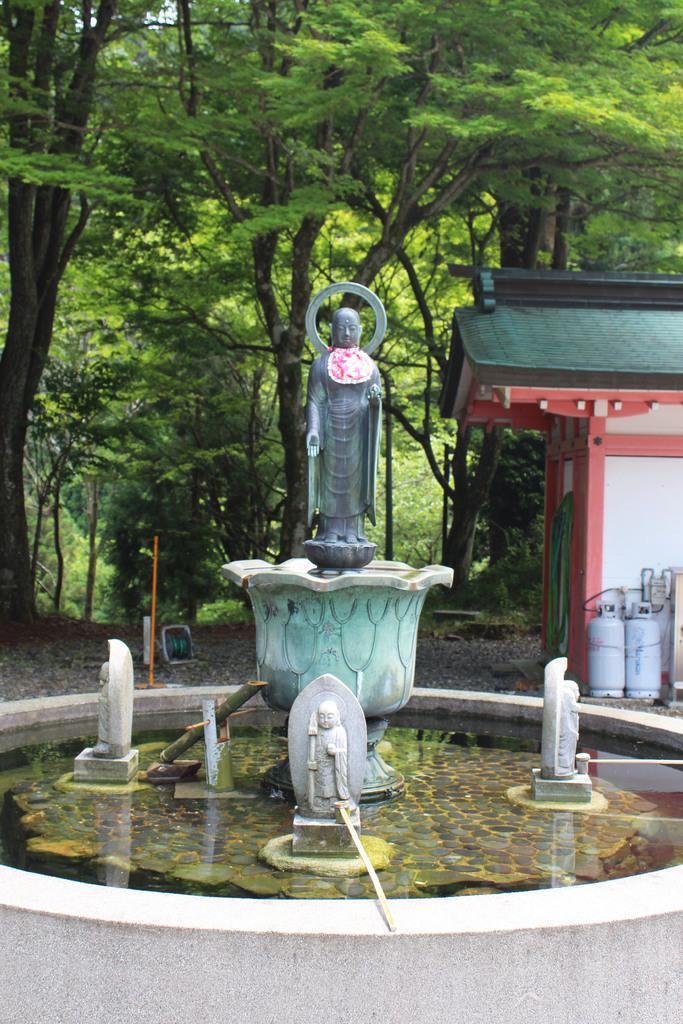In one or two sentences, can you explain what this image depicts? In this image there is a fountain in the middle. In the fountain there are sculptures. In the background there are trees. On the right side there is a house. Beside the house there are two cylinders. 